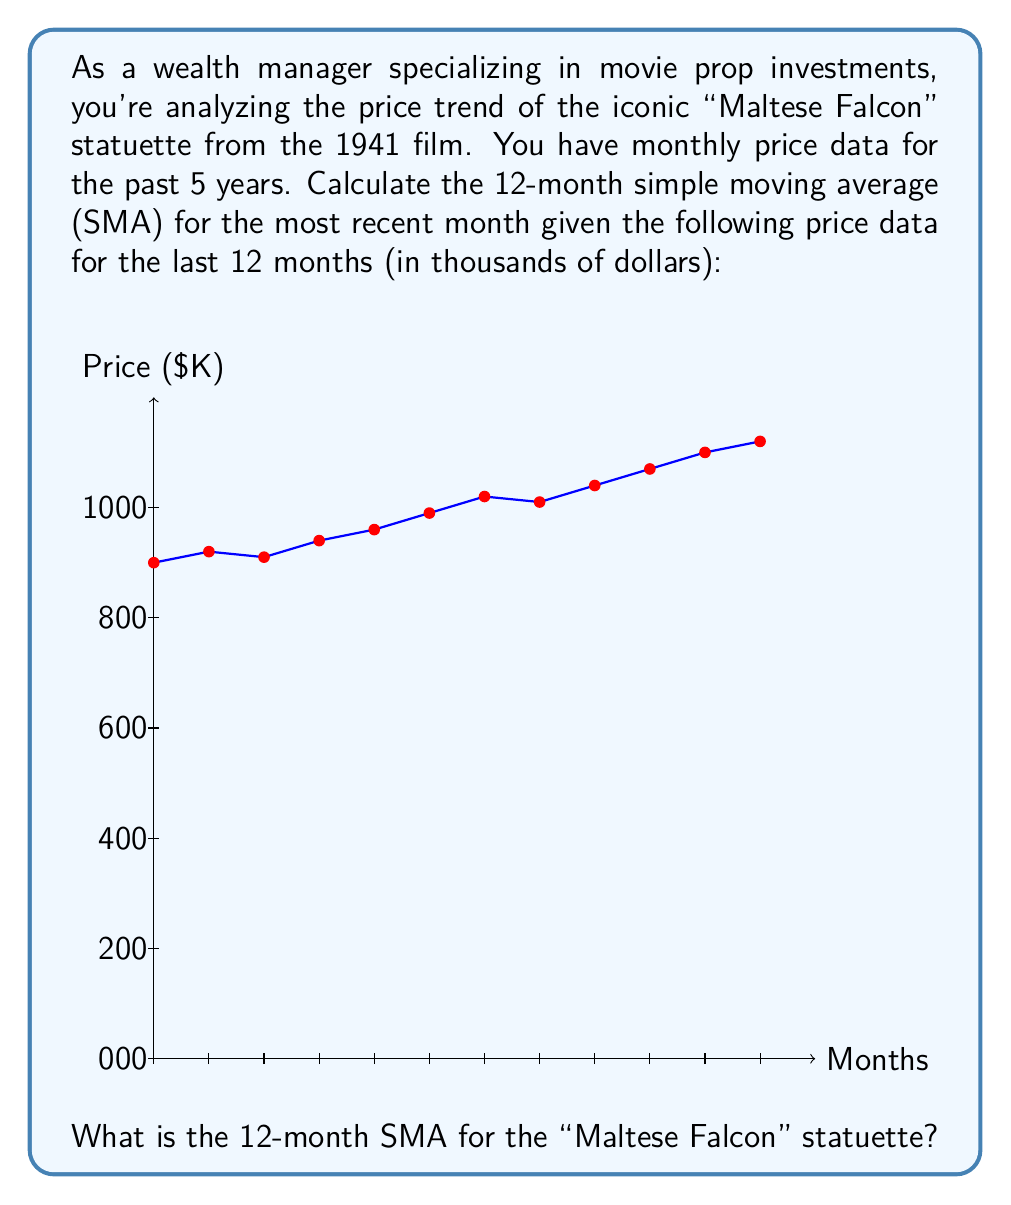Show me your answer to this math problem. To calculate the 12-month simple moving average (SMA), we need to:

1. Sum up the prices for the last 12 months
2. Divide the sum by 12

Let's go through this step-by-step:

1. Sum of the last 12 months' prices:
   $$450 + 460 + 455 + 470 + 480 + 495 + 510 + 505 + 520 + 535 + 550 + 560 = 5990$$

2. Calculate the average by dividing the sum by 12:
   $$\text{SMA} = \frac{\sum_{i=1}^{12} \text{Price}_i}{12} = \frac{5990}{12} = 499.1666...$$

3. Rounding to the nearest thousand dollars (as the original data is in thousands):
   $$\text{SMA} \approx 499$$

Therefore, the 12-month simple moving average for the "Maltese Falcon" statuette is approximately $499,000.
Answer: $499,000 